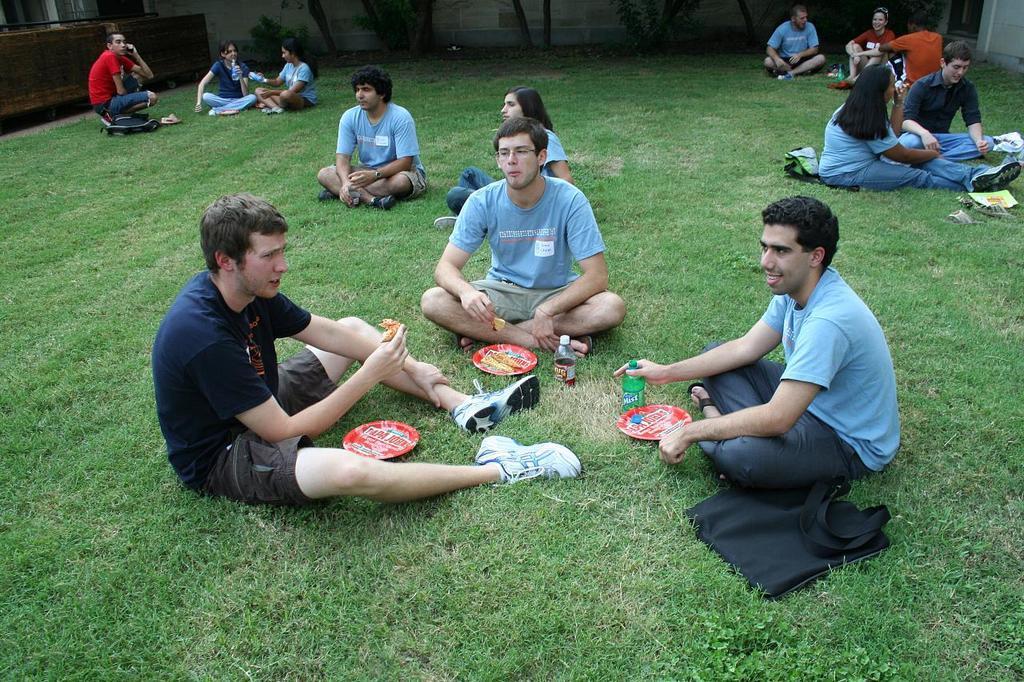Can you describe this image briefly? In the picture I can see three persons sitting on a greenery ground and holding an eatables in their hands and there are few other persons sitting behind them and there is an object in the left top corner. 